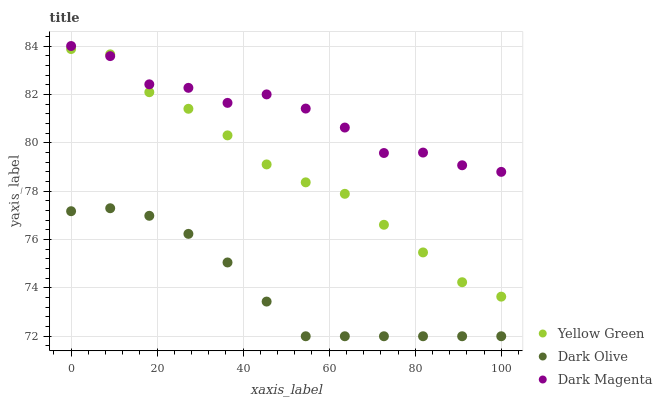Does Dark Olive have the minimum area under the curve?
Answer yes or no. Yes. Does Dark Magenta have the maximum area under the curve?
Answer yes or no. Yes. Does Yellow Green have the minimum area under the curve?
Answer yes or no. No. Does Yellow Green have the maximum area under the curve?
Answer yes or no. No. Is Dark Olive the smoothest?
Answer yes or no. Yes. Is Dark Magenta the roughest?
Answer yes or no. Yes. Is Yellow Green the smoothest?
Answer yes or no. No. Is Yellow Green the roughest?
Answer yes or no. No. Does Dark Olive have the lowest value?
Answer yes or no. Yes. Does Yellow Green have the lowest value?
Answer yes or no. No. Does Dark Magenta have the highest value?
Answer yes or no. Yes. Does Yellow Green have the highest value?
Answer yes or no. No. Is Dark Olive less than Dark Magenta?
Answer yes or no. Yes. Is Dark Magenta greater than Dark Olive?
Answer yes or no. Yes. Does Yellow Green intersect Dark Magenta?
Answer yes or no. Yes. Is Yellow Green less than Dark Magenta?
Answer yes or no. No. Is Yellow Green greater than Dark Magenta?
Answer yes or no. No. Does Dark Olive intersect Dark Magenta?
Answer yes or no. No. 